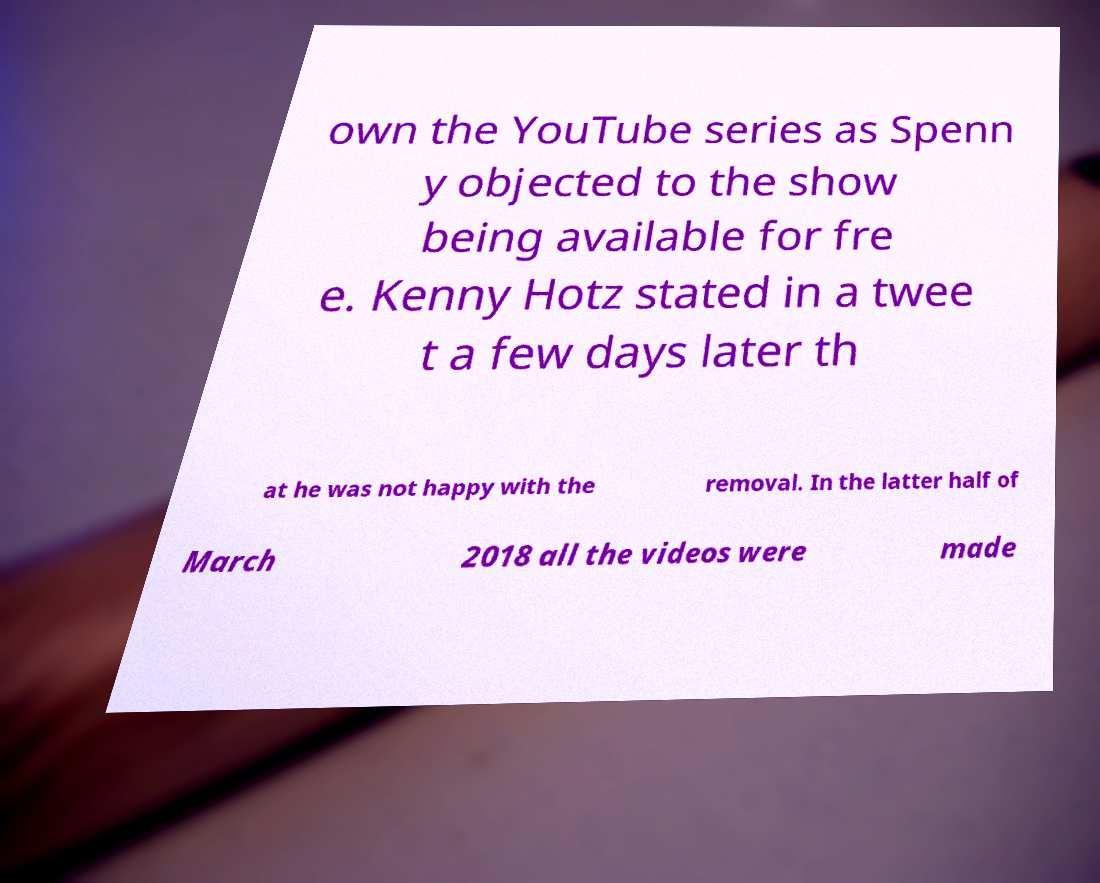Can you read and provide the text displayed in the image?This photo seems to have some interesting text. Can you extract and type it out for me? own the YouTube series as Spenn y objected to the show being available for fre e. Kenny Hotz stated in a twee t a few days later th at he was not happy with the removal. In the latter half of March 2018 all the videos were made 